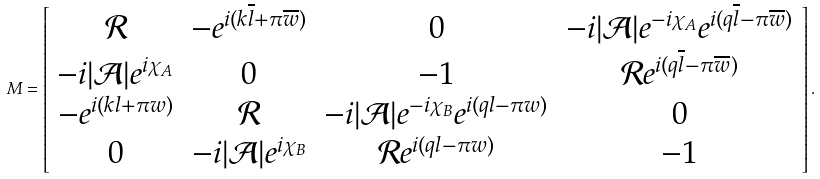Convert formula to latex. <formula><loc_0><loc_0><loc_500><loc_500>M = \left [ \begin{array} { c c c c } \mathcal { R } & - e ^ { i ( k \overline { l } + \pi \overline { w } ) } & 0 & - i | \mathcal { A } | e ^ { - i \chi _ { A } } e ^ { i ( q \overline { l } - \pi \overline { w } ) } \\ - i | \mathcal { A } | e ^ { i \chi _ { A } } & 0 & - 1 & \mathcal { R } e ^ { i ( q \overline { l } - \pi \overline { w } ) } \\ - e ^ { i ( k l + \pi w ) } & \mathcal { R } & - i | \mathcal { A } | e ^ { - i \chi _ { B } } e ^ { i ( q l - \pi w ) } & 0 \\ 0 & - i | \mathcal { A } | e ^ { i \chi _ { B } } & \mathcal { R } e ^ { i ( q l - \pi w ) } & - 1 \end{array} \right ] .</formula> 